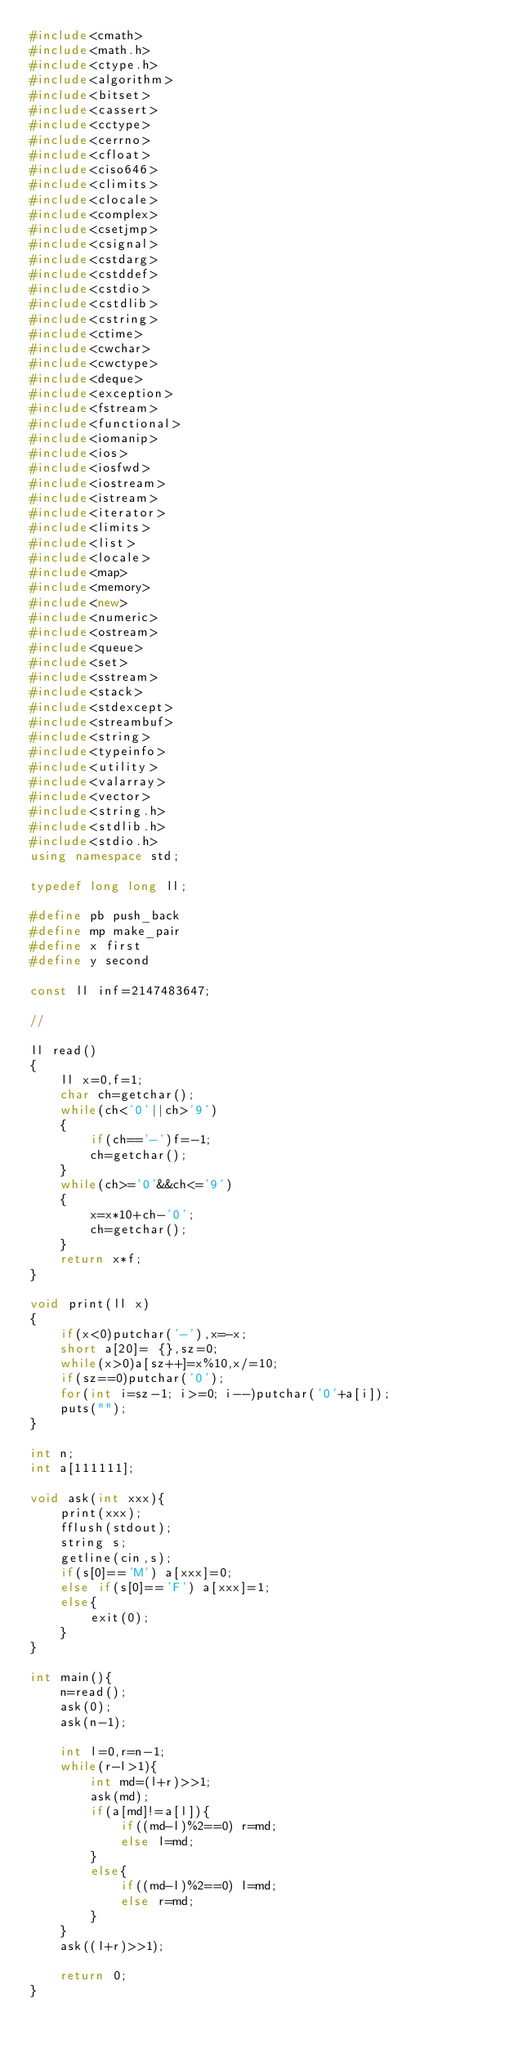<code> <loc_0><loc_0><loc_500><loc_500><_C++_>#include<cmath>
#include<math.h>
#include<ctype.h>
#include<algorithm>
#include<bitset>
#include<cassert>
#include<cctype>
#include<cerrno>
#include<cfloat>
#include<ciso646>
#include<climits>
#include<clocale>
#include<complex>
#include<csetjmp>
#include<csignal>
#include<cstdarg>
#include<cstddef>
#include<cstdio>
#include<cstdlib>
#include<cstring>
#include<ctime>
#include<cwchar>
#include<cwctype>
#include<deque>
#include<exception>
#include<fstream>
#include<functional>
#include<iomanip>
#include<ios>
#include<iosfwd>
#include<iostream>
#include<istream>
#include<iterator>
#include<limits>
#include<list>
#include<locale>
#include<map>
#include<memory>
#include<new>
#include<numeric>
#include<ostream>
#include<queue>
#include<set>
#include<sstream>
#include<stack>
#include<stdexcept>
#include<streambuf>
#include<string>
#include<typeinfo>
#include<utility>
#include<valarray>
#include<vector>
#include<string.h>
#include<stdlib.h>
#include<stdio.h>
using namespace std;

typedef long long ll;

#define pb push_back
#define mp make_pair
#define x first
#define y second

const ll inf=2147483647;

//

ll read()
{
	ll x=0,f=1;
	char ch=getchar();
	while(ch<'0'||ch>'9')
	{
		if(ch=='-')f=-1;
		ch=getchar();
	}
	while(ch>='0'&&ch<='9')
	{
		x=x*10+ch-'0';
		ch=getchar();
	}
	return x*f;
}

void print(ll x)
{
	if(x<0)putchar('-'),x=-x;
	short a[20]= {},sz=0;
	while(x>0)a[sz++]=x%10,x/=10;
	if(sz==0)putchar('0');
	for(int i=sz-1; i>=0; i--)putchar('0'+a[i]);
	puts("");
}

int n;
int a[111111];

void ask(int xxx){
	print(xxx);
	fflush(stdout);
	string s;
	getline(cin,s);
	if(s[0]=='M') a[xxx]=0;
	else if(s[0]=='F') a[xxx]=1;
	else{
		exit(0);
	}
}

int main(){
	n=read();
	ask(0);
	ask(n-1);
	
	int l=0,r=n-1;
	while(r-l>1){
		int md=(l+r)>>1;
		ask(md);
		if(a[md]!=a[l]){
			if((md-l)%2==0) r=md;
			else l=md;
		}
		else{
			if((md-l)%2==0) l=md;
			else r=md;
		}
	}
	ask((l+r)>>1);
	
	return 0;
}</code> 